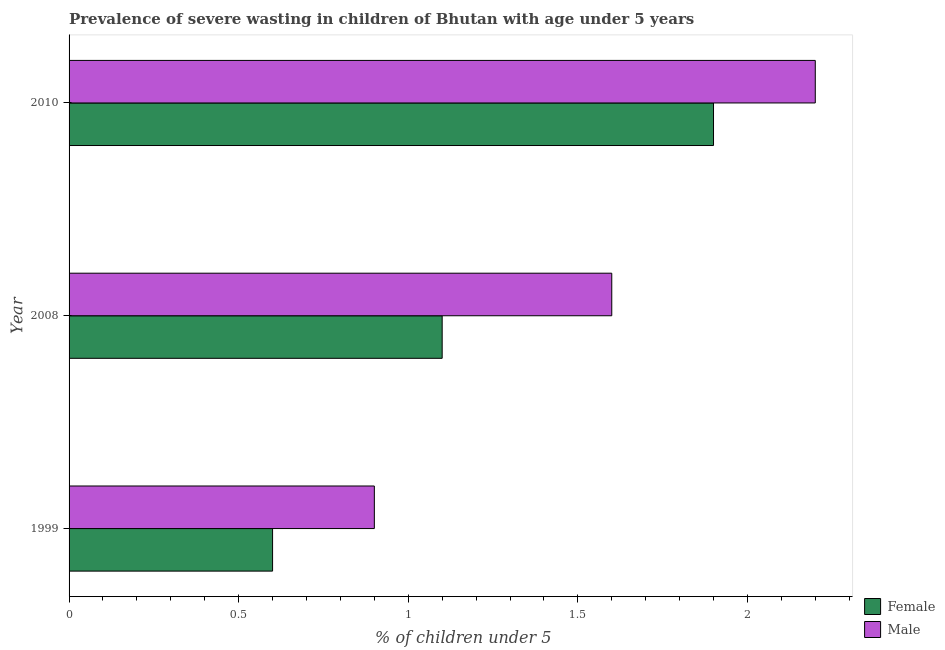How many groups of bars are there?
Give a very brief answer. 3. Are the number of bars on each tick of the Y-axis equal?
Your answer should be very brief. Yes. How many bars are there on the 2nd tick from the top?
Offer a very short reply. 2. What is the percentage of undernourished male children in 1999?
Offer a very short reply. 0.9. Across all years, what is the maximum percentage of undernourished female children?
Give a very brief answer. 1.9. Across all years, what is the minimum percentage of undernourished female children?
Make the answer very short. 0.6. In which year was the percentage of undernourished female children maximum?
Provide a short and direct response. 2010. What is the total percentage of undernourished male children in the graph?
Keep it short and to the point. 4.7. What is the difference between the percentage of undernourished male children in 2010 and the percentage of undernourished female children in 1999?
Offer a terse response. 1.6. What is the average percentage of undernourished male children per year?
Give a very brief answer. 1.57. What is the ratio of the percentage of undernourished female children in 1999 to that in 2010?
Offer a very short reply. 0.32. Is the percentage of undernourished male children in 1999 less than that in 2010?
Keep it short and to the point. Yes. What is the difference between the highest and the lowest percentage of undernourished female children?
Offer a very short reply. 1.3. How many years are there in the graph?
Your answer should be very brief. 3. What is the difference between two consecutive major ticks on the X-axis?
Make the answer very short. 0.5. Where does the legend appear in the graph?
Ensure brevity in your answer.  Bottom right. How many legend labels are there?
Keep it short and to the point. 2. How are the legend labels stacked?
Make the answer very short. Vertical. What is the title of the graph?
Ensure brevity in your answer.  Prevalence of severe wasting in children of Bhutan with age under 5 years. Does "Rural" appear as one of the legend labels in the graph?
Make the answer very short. No. What is the label or title of the X-axis?
Make the answer very short.  % of children under 5. What is the  % of children under 5 in Female in 1999?
Your answer should be very brief. 0.6. What is the  % of children under 5 of Male in 1999?
Provide a succinct answer. 0.9. What is the  % of children under 5 in Female in 2008?
Your answer should be very brief. 1.1. What is the  % of children under 5 in Male in 2008?
Your answer should be compact. 1.6. What is the  % of children under 5 of Female in 2010?
Provide a short and direct response. 1.9. What is the  % of children under 5 of Male in 2010?
Provide a succinct answer. 2.2. Across all years, what is the maximum  % of children under 5 of Female?
Make the answer very short. 1.9. Across all years, what is the maximum  % of children under 5 of Male?
Keep it short and to the point. 2.2. Across all years, what is the minimum  % of children under 5 of Female?
Your answer should be compact. 0.6. Across all years, what is the minimum  % of children under 5 of Male?
Provide a short and direct response. 0.9. What is the total  % of children under 5 in Female in the graph?
Your answer should be very brief. 3.6. What is the difference between the  % of children under 5 in Male in 1999 and that in 2008?
Provide a short and direct response. -0.7. What is the difference between the  % of children under 5 in Female in 1999 and that in 2010?
Your response must be concise. -1.3. What is the difference between the  % of children under 5 of Male in 1999 and that in 2010?
Give a very brief answer. -1.3. What is the difference between the  % of children under 5 of Male in 2008 and that in 2010?
Your response must be concise. -0.6. What is the difference between the  % of children under 5 of Female in 1999 and the  % of children under 5 of Male in 2010?
Ensure brevity in your answer.  -1.6. What is the difference between the  % of children under 5 in Female in 2008 and the  % of children under 5 in Male in 2010?
Keep it short and to the point. -1.1. What is the average  % of children under 5 of Male per year?
Your answer should be very brief. 1.57. In the year 2008, what is the difference between the  % of children under 5 in Female and  % of children under 5 in Male?
Give a very brief answer. -0.5. In the year 2010, what is the difference between the  % of children under 5 of Female and  % of children under 5 of Male?
Offer a terse response. -0.3. What is the ratio of the  % of children under 5 in Female in 1999 to that in 2008?
Offer a terse response. 0.55. What is the ratio of the  % of children under 5 in Male in 1999 to that in 2008?
Provide a succinct answer. 0.56. What is the ratio of the  % of children under 5 of Female in 1999 to that in 2010?
Provide a succinct answer. 0.32. What is the ratio of the  % of children under 5 in Male in 1999 to that in 2010?
Your response must be concise. 0.41. What is the ratio of the  % of children under 5 in Female in 2008 to that in 2010?
Offer a very short reply. 0.58. What is the ratio of the  % of children under 5 of Male in 2008 to that in 2010?
Your answer should be very brief. 0.73. What is the difference between the highest and the second highest  % of children under 5 in Female?
Offer a terse response. 0.8. What is the difference between the highest and the lowest  % of children under 5 in Female?
Make the answer very short. 1.3. What is the difference between the highest and the lowest  % of children under 5 in Male?
Ensure brevity in your answer.  1.3. 